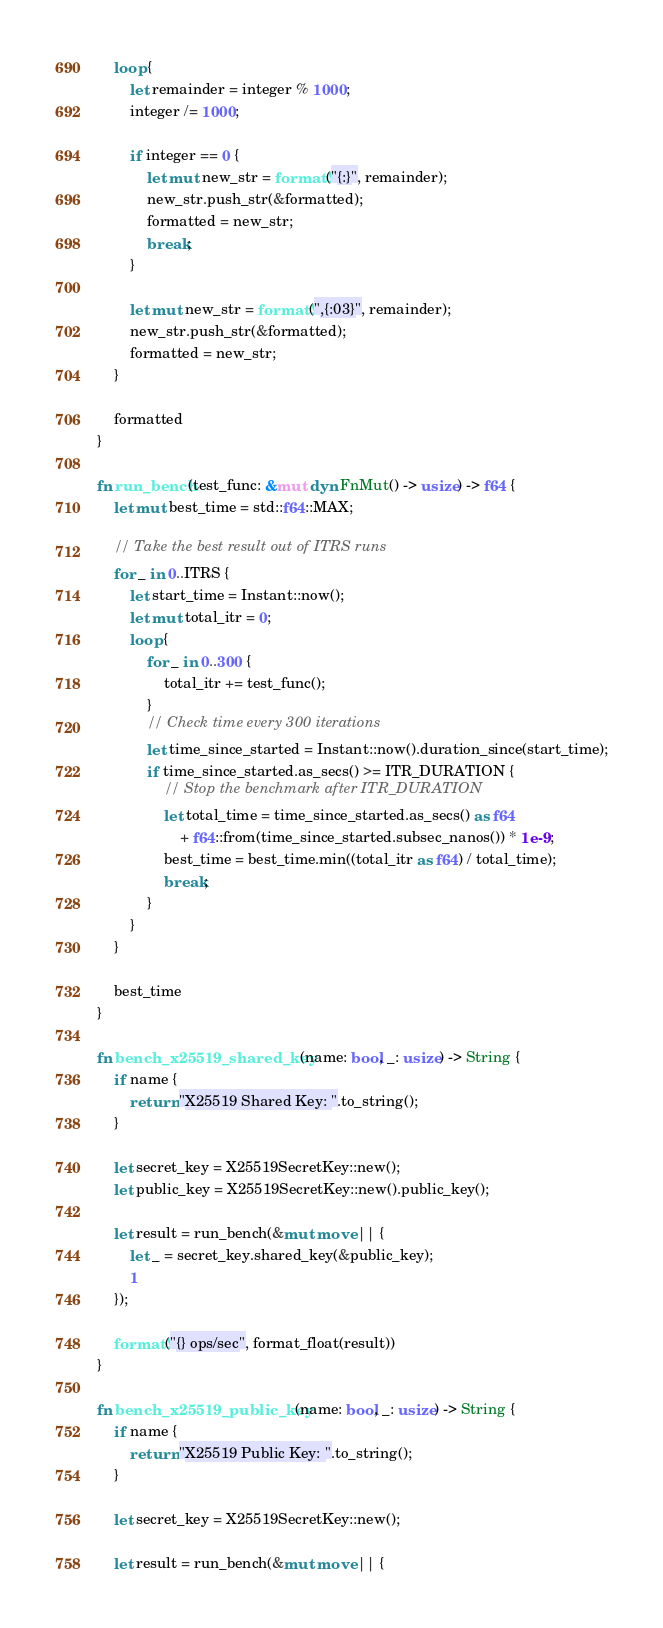<code> <loc_0><loc_0><loc_500><loc_500><_Rust_>    loop {
        let remainder = integer % 1000;
        integer /= 1000;

        if integer == 0 {
            let mut new_str = format!("{:}", remainder);
            new_str.push_str(&formatted);
            formatted = new_str;
            break;
        }

        let mut new_str = format!(",{:03}", remainder);
        new_str.push_str(&formatted);
        formatted = new_str;
    }

    formatted
}

fn run_bench(test_func: &mut dyn FnMut() -> usize) -> f64 {
    let mut best_time = std::f64::MAX;

    // Take the best result out of ITRS runs
    for _ in 0..ITRS {
        let start_time = Instant::now();
        let mut total_itr = 0;
        loop {
            for _ in 0..300 {
                total_itr += test_func();
            }
            // Check time every 300 iterations
            let time_since_started = Instant::now().duration_since(start_time);
            if time_since_started.as_secs() >= ITR_DURATION {
                // Stop the benchmark after ITR_DURATION
                let total_time = time_since_started.as_secs() as f64
                    + f64::from(time_since_started.subsec_nanos()) * 1e-9;
                best_time = best_time.min((total_itr as f64) / total_time);
                break;
            }
        }
    }

    best_time
}

fn bench_x25519_shared_key(name: bool, _: usize) -> String {
    if name {
        return "X25519 Shared Key: ".to_string();
    }

    let secret_key = X25519SecretKey::new();
    let public_key = X25519SecretKey::new().public_key();

    let result = run_bench(&mut move || {
        let _ = secret_key.shared_key(&public_key);
        1
    });

    format!("{} ops/sec", format_float(result))
}

fn bench_x25519_public_key(name: bool, _: usize) -> String {
    if name {
        return "X25519 Public Key: ".to_string();
    }

    let secret_key = X25519SecretKey::new();

    let result = run_bench(&mut move || {</code> 